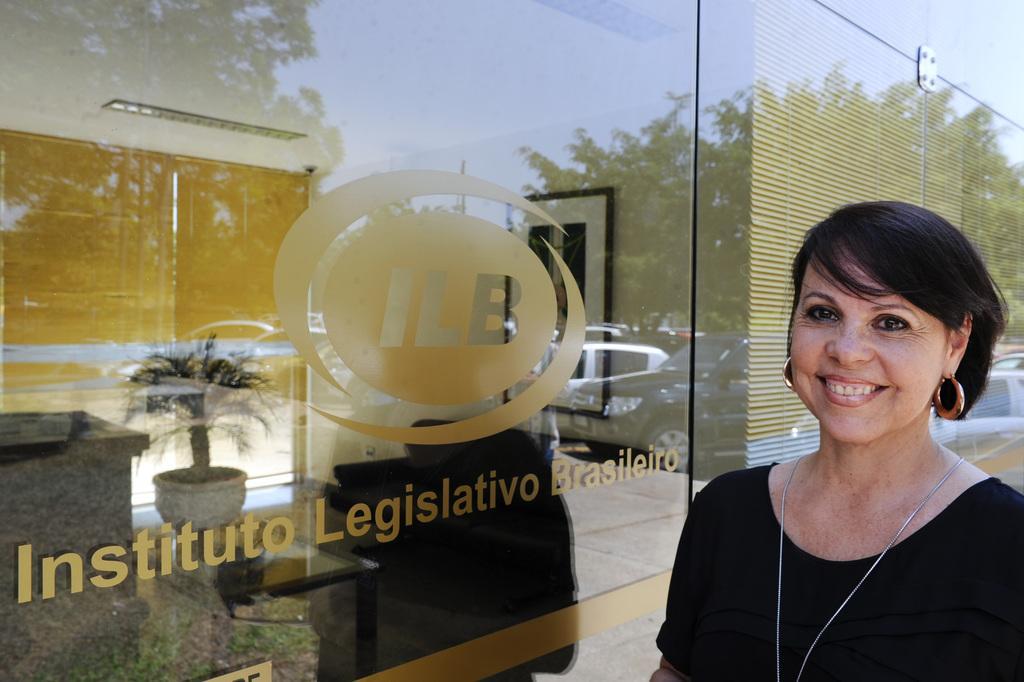Can you describe this image briefly? On the right side there is a lady wearing earrings and chain is smiling. Near to her there is a building with glass wall with a logo and something written on that. Through that we can see a pot with a plant on a table and also there is a photo frame on the wall. 